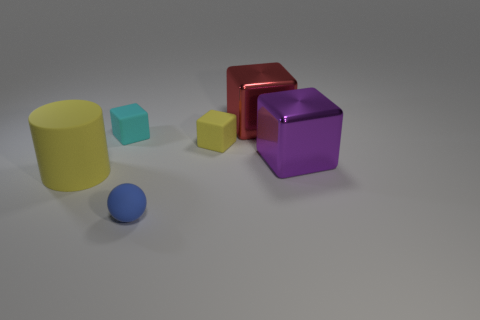Add 1 big red things. How many objects exist? 7 Subtract all blue cubes. Subtract all cyan balls. How many cubes are left? 4 Subtract 1 yellow blocks. How many objects are left? 5 Subtract all cylinders. How many objects are left? 5 Subtract all red cylinders. Subtract all blue matte things. How many objects are left? 5 Add 4 cubes. How many cubes are left? 8 Add 6 large red blocks. How many large red blocks exist? 7 